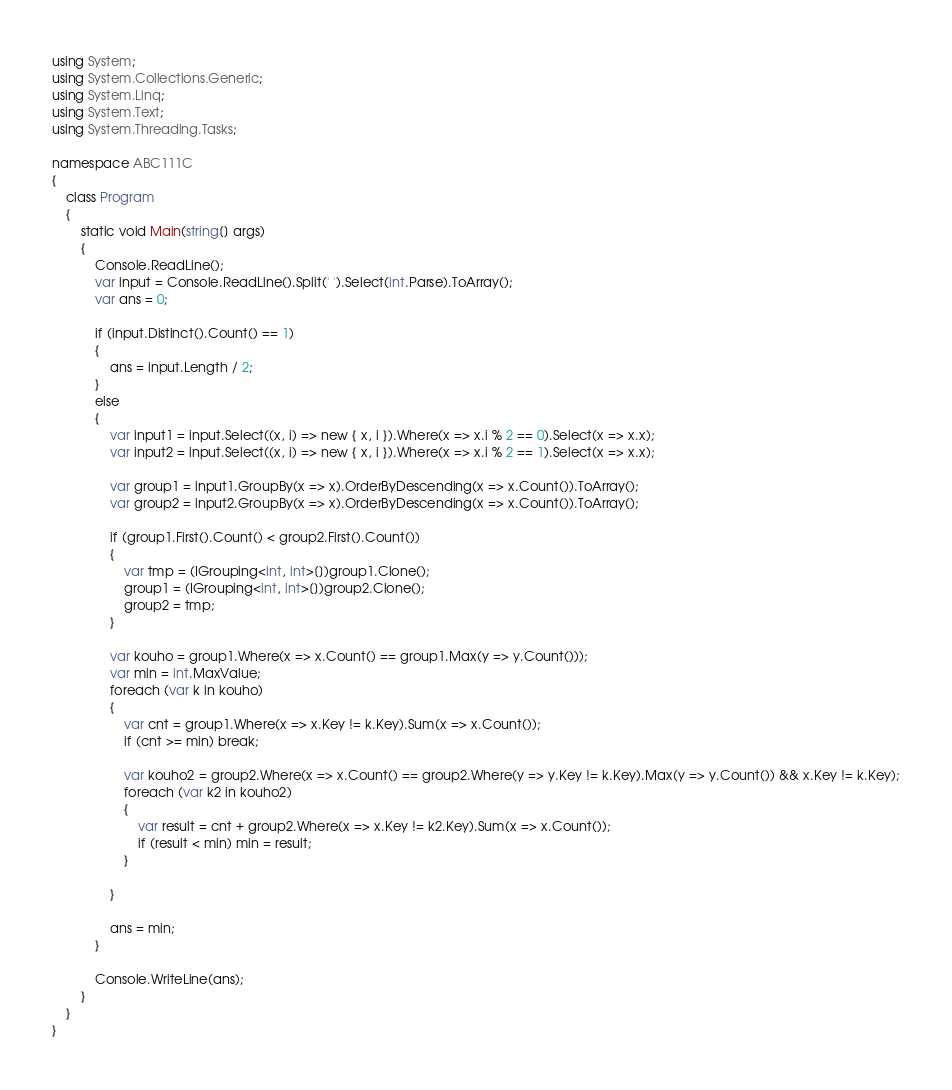Convert code to text. <code><loc_0><loc_0><loc_500><loc_500><_C#_>using System;
using System.Collections.Generic;
using System.Linq;
using System.Text;
using System.Threading.Tasks;

namespace ABC111C
{
    class Program
    {
        static void Main(string[] args)
        {
            Console.ReadLine();
            var input = Console.ReadLine().Split(' ').Select(int.Parse).ToArray();
            var ans = 0;

            if (input.Distinct().Count() == 1)
            {
                ans = input.Length / 2;
            }
            else
            {
                var input1 = input.Select((x, i) => new { x, i }).Where(x => x.i % 2 == 0).Select(x => x.x);
                var input2 = input.Select((x, i) => new { x, i }).Where(x => x.i % 2 == 1).Select(x => x.x);

                var group1 = input1.GroupBy(x => x).OrderByDescending(x => x.Count()).ToArray();
                var group2 = input2.GroupBy(x => x).OrderByDescending(x => x.Count()).ToArray();

                if (group1.First().Count() < group2.First().Count())
                {
                    var tmp = (IGrouping<int, int>[])group1.Clone();
                    group1 = (IGrouping<int, int>[])group2.Clone();
                    group2 = tmp;
                }

                var kouho = group1.Where(x => x.Count() == group1.Max(y => y.Count()));
                var min = int.MaxValue;
                foreach (var k in kouho)
                {
                    var cnt = group1.Where(x => x.Key != k.Key).Sum(x => x.Count());
                    if (cnt >= min) break;

                    var kouho2 = group2.Where(x => x.Count() == group2.Where(y => y.Key != k.Key).Max(y => y.Count()) && x.Key != k.Key);
                    foreach (var k2 in kouho2)
                    {
                        var result = cnt + group2.Where(x => x.Key != k2.Key).Sum(x => x.Count());
                        if (result < min) min = result;
                    }

                }

                ans = min;
            }

            Console.WriteLine(ans);
        }
    }
}
</code> 